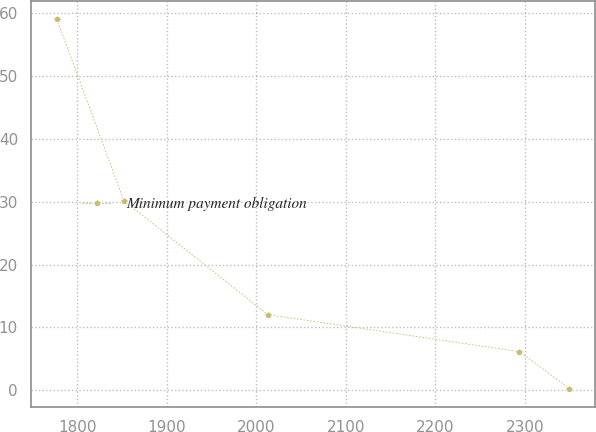<chart> <loc_0><loc_0><loc_500><loc_500><line_chart><ecel><fcel>Minimum payment obligation<nl><fcel>1776.93<fcel>58.99<nl><fcel>1851.88<fcel>30.14<nl><fcel>2012.65<fcel>12.04<nl><fcel>2293.88<fcel>6.17<nl><fcel>2349.81<fcel>0.3<nl></chart> 